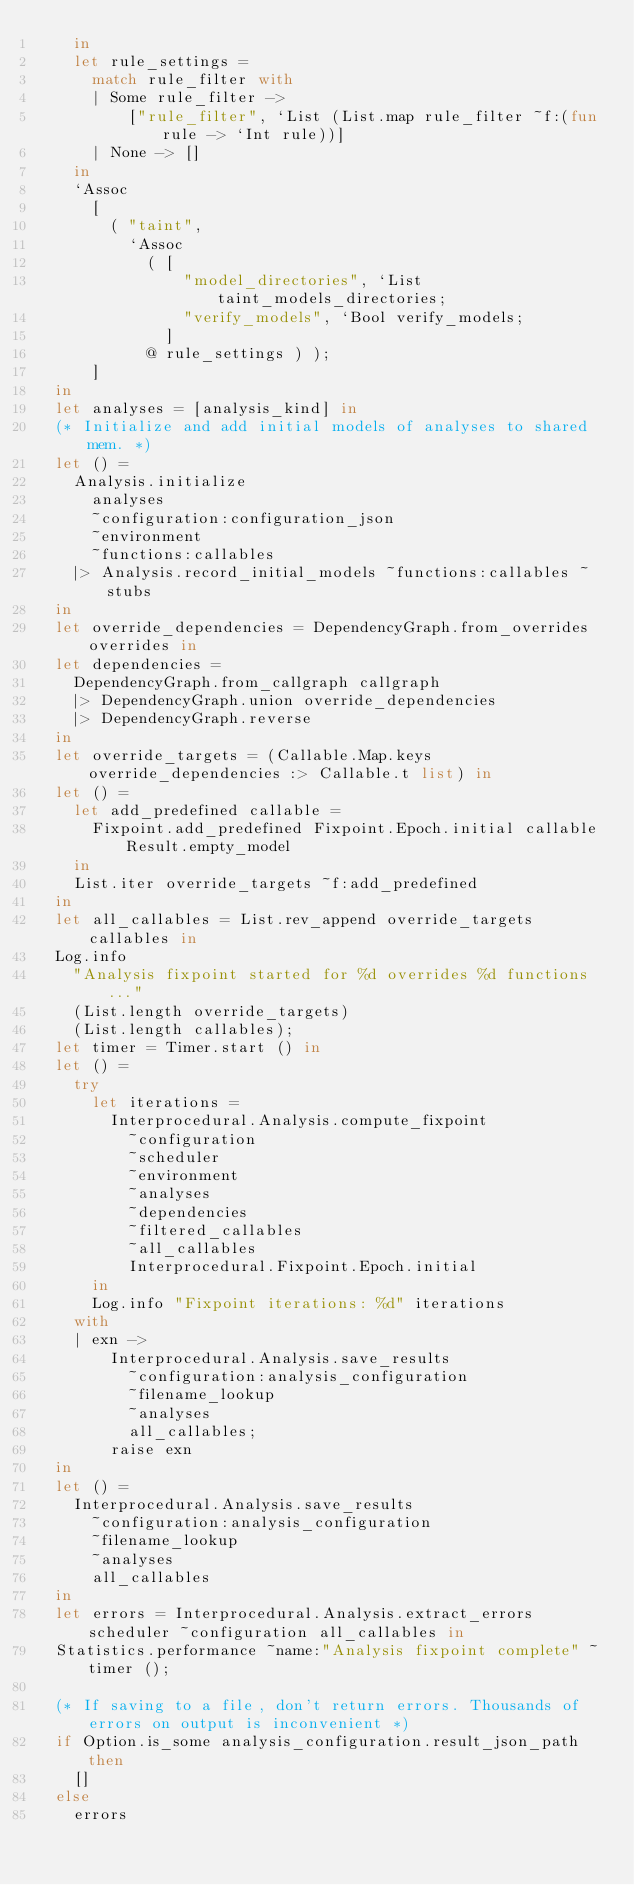Convert code to text. <code><loc_0><loc_0><loc_500><loc_500><_OCaml_>    in
    let rule_settings =
      match rule_filter with
      | Some rule_filter ->
          ["rule_filter", `List (List.map rule_filter ~f:(fun rule -> `Int rule))]
      | None -> []
    in
    `Assoc
      [
        ( "taint",
          `Assoc
            ( [
                "model_directories", `List taint_models_directories;
                "verify_models", `Bool verify_models;
              ]
            @ rule_settings ) );
      ]
  in
  let analyses = [analysis_kind] in
  (* Initialize and add initial models of analyses to shared mem. *)
  let () =
    Analysis.initialize
      analyses
      ~configuration:configuration_json
      ~environment
      ~functions:callables
    |> Analysis.record_initial_models ~functions:callables ~stubs
  in
  let override_dependencies = DependencyGraph.from_overrides overrides in
  let dependencies =
    DependencyGraph.from_callgraph callgraph
    |> DependencyGraph.union override_dependencies
    |> DependencyGraph.reverse
  in
  let override_targets = (Callable.Map.keys override_dependencies :> Callable.t list) in
  let () =
    let add_predefined callable =
      Fixpoint.add_predefined Fixpoint.Epoch.initial callable Result.empty_model
    in
    List.iter override_targets ~f:add_predefined
  in
  let all_callables = List.rev_append override_targets callables in
  Log.info
    "Analysis fixpoint started for %d overrides %d functions..."
    (List.length override_targets)
    (List.length callables);
  let timer = Timer.start () in
  let () =
    try
      let iterations =
        Interprocedural.Analysis.compute_fixpoint
          ~configuration
          ~scheduler
          ~environment
          ~analyses
          ~dependencies
          ~filtered_callables
          ~all_callables
          Interprocedural.Fixpoint.Epoch.initial
      in
      Log.info "Fixpoint iterations: %d" iterations
    with
    | exn ->
        Interprocedural.Analysis.save_results
          ~configuration:analysis_configuration
          ~filename_lookup
          ~analyses
          all_callables;
        raise exn
  in
  let () =
    Interprocedural.Analysis.save_results
      ~configuration:analysis_configuration
      ~filename_lookup
      ~analyses
      all_callables
  in
  let errors = Interprocedural.Analysis.extract_errors scheduler ~configuration all_callables in
  Statistics.performance ~name:"Analysis fixpoint complete" ~timer ();

  (* If saving to a file, don't return errors. Thousands of errors on output is inconvenient *)
  if Option.is_some analysis_configuration.result_json_path then
    []
  else
    errors
</code> 